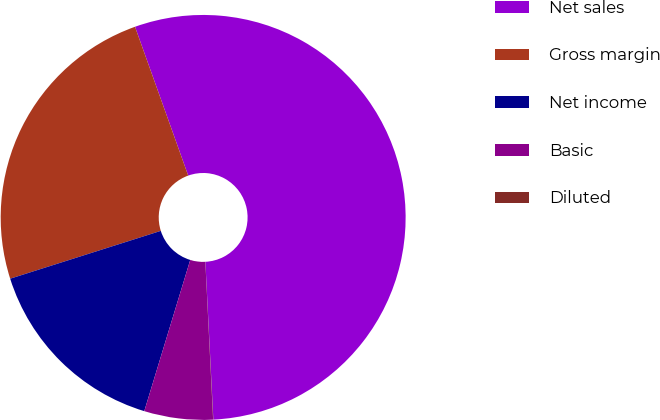<chart> <loc_0><loc_0><loc_500><loc_500><pie_chart><fcel>Net sales<fcel>Gross margin<fcel>Net income<fcel>Basic<fcel>Diluted<nl><fcel>54.66%<fcel>24.43%<fcel>15.41%<fcel>5.48%<fcel>0.02%<nl></chart> 